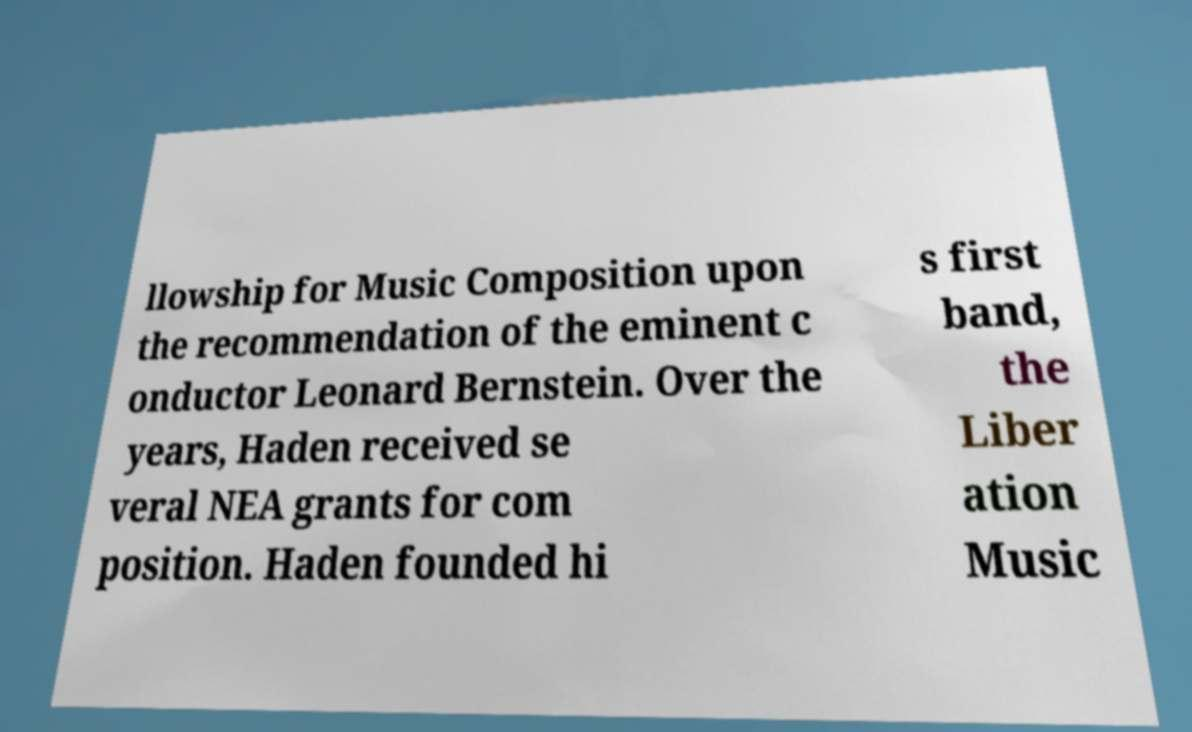I need the written content from this picture converted into text. Can you do that? llowship for Music Composition upon the recommendation of the eminent c onductor Leonard Bernstein. Over the years, Haden received se veral NEA grants for com position. Haden founded hi s first band, the Liber ation Music 